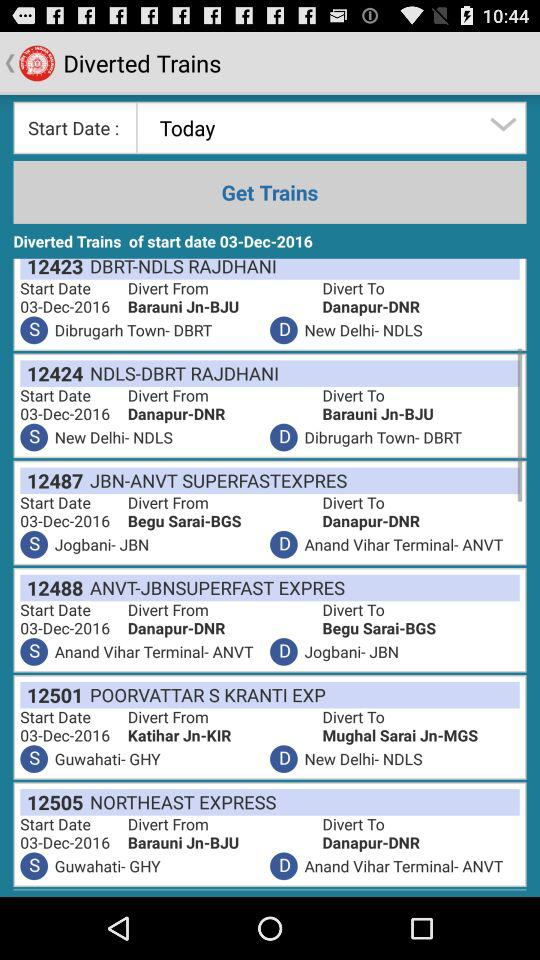What is the number of train "NORTHEAST EXPRESS"? The number is 12505. 